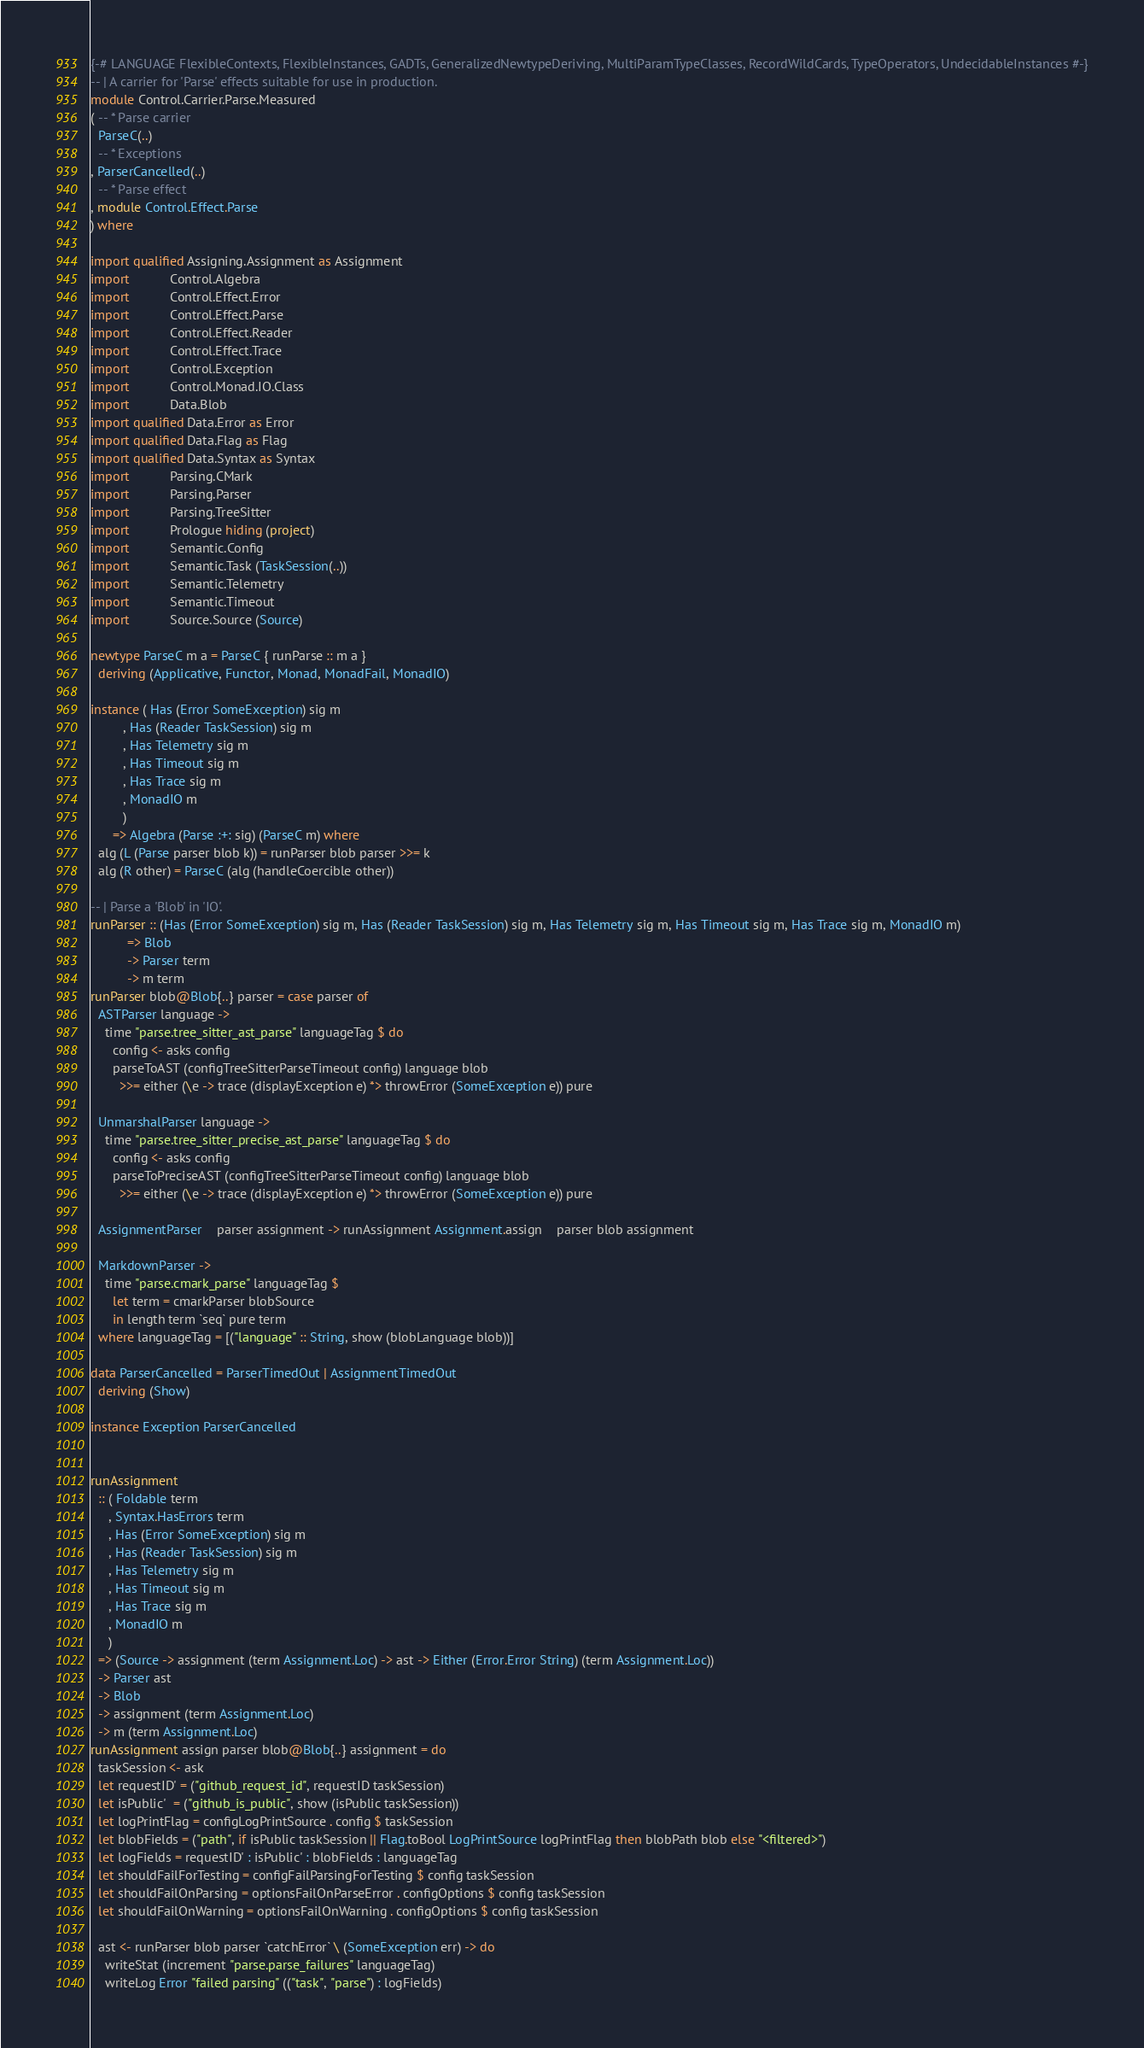<code> <loc_0><loc_0><loc_500><loc_500><_Haskell_>{-# LANGUAGE FlexibleContexts, FlexibleInstances, GADTs, GeneralizedNewtypeDeriving, MultiParamTypeClasses, RecordWildCards, TypeOperators, UndecidableInstances #-}
-- | A carrier for 'Parse' effects suitable for use in production.
module Control.Carrier.Parse.Measured
( -- * Parse carrier
  ParseC(..)
  -- * Exceptions
, ParserCancelled(..)
  -- * Parse effect
, module Control.Effect.Parse
) where

import qualified Assigning.Assignment as Assignment
import           Control.Algebra
import           Control.Effect.Error
import           Control.Effect.Parse
import           Control.Effect.Reader
import           Control.Effect.Trace
import           Control.Exception
import           Control.Monad.IO.Class
import           Data.Blob
import qualified Data.Error as Error
import qualified Data.Flag as Flag
import qualified Data.Syntax as Syntax
import           Parsing.CMark
import           Parsing.Parser
import           Parsing.TreeSitter
import           Prologue hiding (project)
import           Semantic.Config
import           Semantic.Task (TaskSession(..))
import           Semantic.Telemetry
import           Semantic.Timeout
import           Source.Source (Source)

newtype ParseC m a = ParseC { runParse :: m a }
  deriving (Applicative, Functor, Monad, MonadFail, MonadIO)

instance ( Has (Error SomeException) sig m
         , Has (Reader TaskSession) sig m
         , Has Telemetry sig m
         , Has Timeout sig m
         , Has Trace sig m
         , MonadIO m
         )
      => Algebra (Parse :+: sig) (ParseC m) where
  alg (L (Parse parser blob k)) = runParser blob parser >>= k
  alg (R other) = ParseC (alg (handleCoercible other))

-- | Parse a 'Blob' in 'IO'.
runParser :: (Has (Error SomeException) sig m, Has (Reader TaskSession) sig m, Has Telemetry sig m, Has Timeout sig m, Has Trace sig m, MonadIO m)
          => Blob
          -> Parser term
          -> m term
runParser blob@Blob{..} parser = case parser of
  ASTParser language ->
    time "parse.tree_sitter_ast_parse" languageTag $ do
      config <- asks config
      parseToAST (configTreeSitterParseTimeout config) language blob
        >>= either (\e -> trace (displayException e) *> throwError (SomeException e)) pure

  UnmarshalParser language ->
    time "parse.tree_sitter_precise_ast_parse" languageTag $ do
      config <- asks config
      parseToPreciseAST (configTreeSitterParseTimeout config) language blob
        >>= either (\e -> trace (displayException e) *> throwError (SomeException e)) pure

  AssignmentParser    parser assignment -> runAssignment Assignment.assign    parser blob assignment

  MarkdownParser ->
    time "parse.cmark_parse" languageTag $
      let term = cmarkParser blobSource
      in length term `seq` pure term
  where languageTag = [("language" :: String, show (blobLanguage blob))]

data ParserCancelled = ParserTimedOut | AssignmentTimedOut
  deriving (Show)

instance Exception ParserCancelled


runAssignment
  :: ( Foldable term
     , Syntax.HasErrors term
     , Has (Error SomeException) sig m
     , Has (Reader TaskSession) sig m
     , Has Telemetry sig m
     , Has Timeout sig m
     , Has Trace sig m
     , MonadIO m
     )
  => (Source -> assignment (term Assignment.Loc) -> ast -> Either (Error.Error String) (term Assignment.Loc))
  -> Parser ast
  -> Blob
  -> assignment (term Assignment.Loc)
  -> m (term Assignment.Loc)
runAssignment assign parser blob@Blob{..} assignment = do
  taskSession <- ask
  let requestID' = ("github_request_id", requestID taskSession)
  let isPublic'  = ("github_is_public", show (isPublic taskSession))
  let logPrintFlag = configLogPrintSource . config $ taskSession
  let blobFields = ("path", if isPublic taskSession || Flag.toBool LogPrintSource logPrintFlag then blobPath blob else "<filtered>")
  let logFields = requestID' : isPublic' : blobFields : languageTag
  let shouldFailForTesting = configFailParsingForTesting $ config taskSession
  let shouldFailOnParsing = optionsFailOnParseError . configOptions $ config taskSession
  let shouldFailOnWarning = optionsFailOnWarning . configOptions $ config taskSession

  ast <- runParser blob parser `catchError` \ (SomeException err) -> do
    writeStat (increment "parse.parse_failures" languageTag)
    writeLog Error "failed parsing" (("task", "parse") : logFields)</code> 